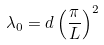<formula> <loc_0><loc_0><loc_500><loc_500>\lambda _ { 0 } = d \left ( \frac { \pi } { L } \right ) ^ { 2 }</formula> 